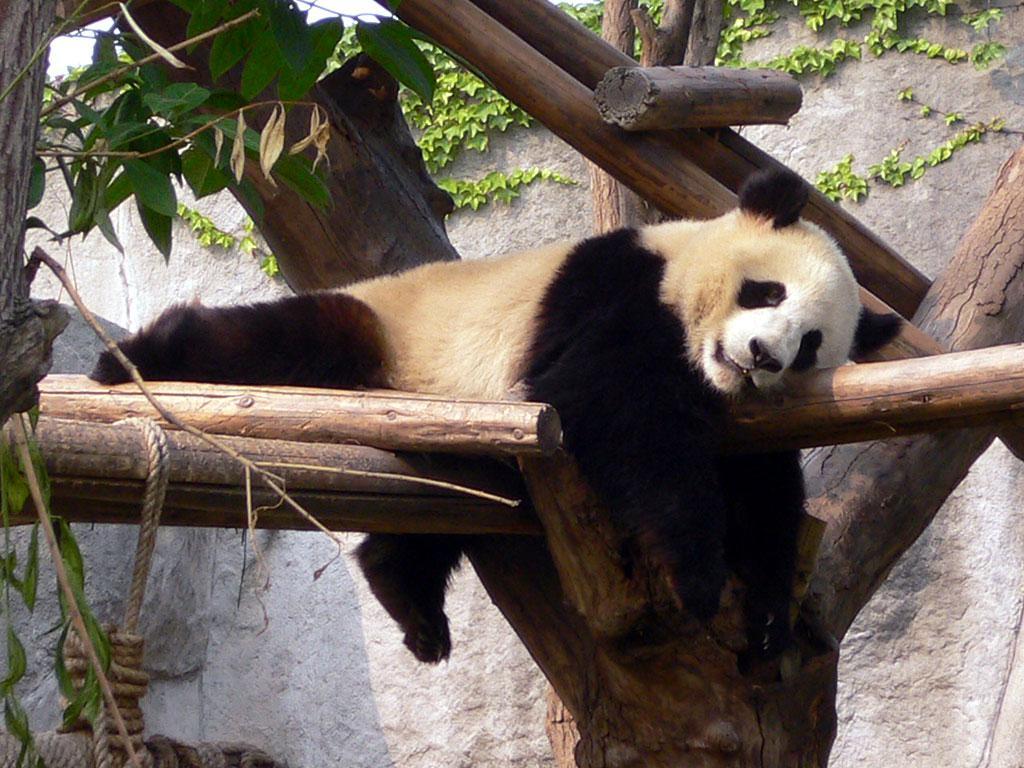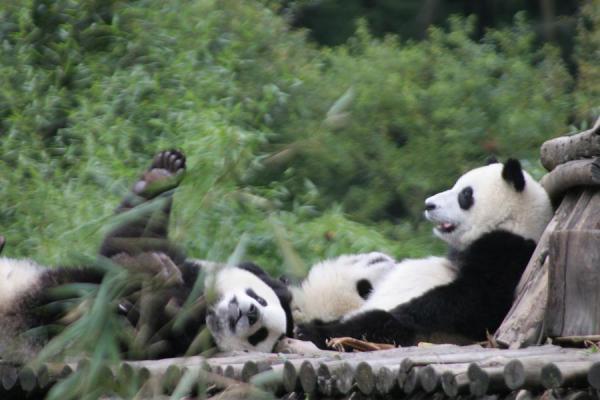The first image is the image on the left, the second image is the image on the right. Analyze the images presented: Is the assertion "One of the pandas is lounging on a large rock." valid? Answer yes or no. No. The first image is the image on the left, the second image is the image on the right. For the images displayed, is the sentence "In one image there is a panda bear sleeping on a log." factually correct? Answer yes or no. Yes. 